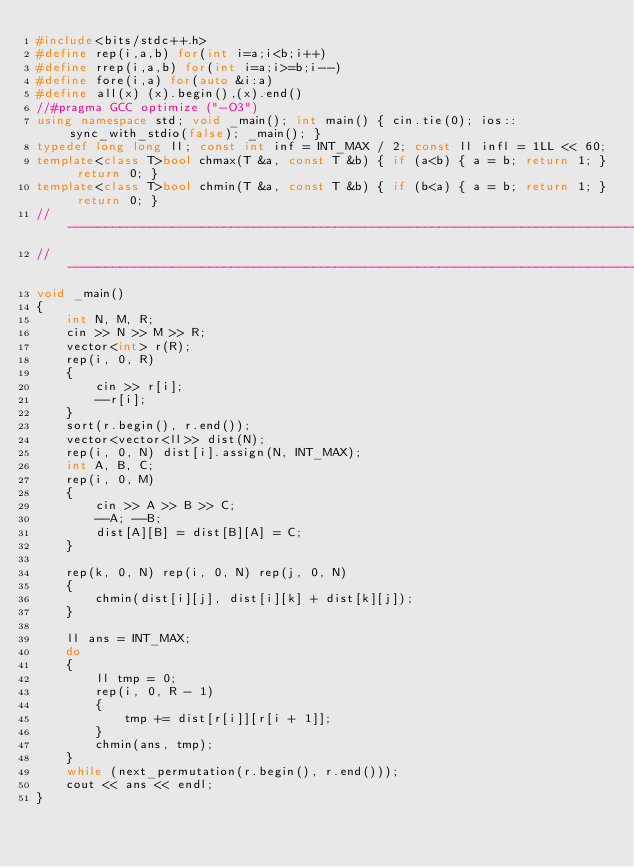<code> <loc_0><loc_0><loc_500><loc_500><_C++_>#include<bits/stdc++.h>
#define rep(i,a,b) for(int i=a;i<b;i++)
#define rrep(i,a,b) for(int i=a;i>=b;i--)
#define fore(i,a) for(auto &i:a)
#define all(x) (x).begin(),(x).end()
//#pragma GCC optimize ("-O3")
using namespace std; void _main(); int main() { cin.tie(0); ios::sync_with_stdio(false); _main(); }
typedef long long ll; const int inf = INT_MAX / 2; const ll infl = 1LL << 60;
template<class T>bool chmax(T &a, const T &b) { if (a<b) { a = b; return 1; } return 0; }
template<class T>bool chmin(T &a, const T &b) { if (b<a) { a = b; return 1; } return 0; }
//------------------------------------------------------------------------------
//------------------------------------------------------------------------------
void _main()
{
    int N, M, R;
    cin >> N >> M >> R;
    vector<int> r(R);
    rep(i, 0, R)
    {
        cin >> r[i];
        --r[i];
    }
    sort(r.begin(), r.end());
    vector<vector<ll>> dist(N);
    rep(i, 0, N) dist[i].assign(N, INT_MAX);
    int A, B, C;
    rep(i, 0, M)
    {
        cin >> A >> B >> C;
        --A; --B;
        dist[A][B] = dist[B][A] = C;
    }

    rep(k, 0, N) rep(i, 0, N) rep(j, 0, N)
    {
        chmin(dist[i][j], dist[i][k] + dist[k][j]);
    }

    ll ans = INT_MAX;
    do
    {
        ll tmp = 0;
        rep(i, 0, R - 1)
        {
            tmp += dist[r[i]][r[i + 1]];
        }
        chmin(ans, tmp);
    }
    while (next_permutation(r.begin(), r.end()));
    cout << ans << endl;
}
</code> 